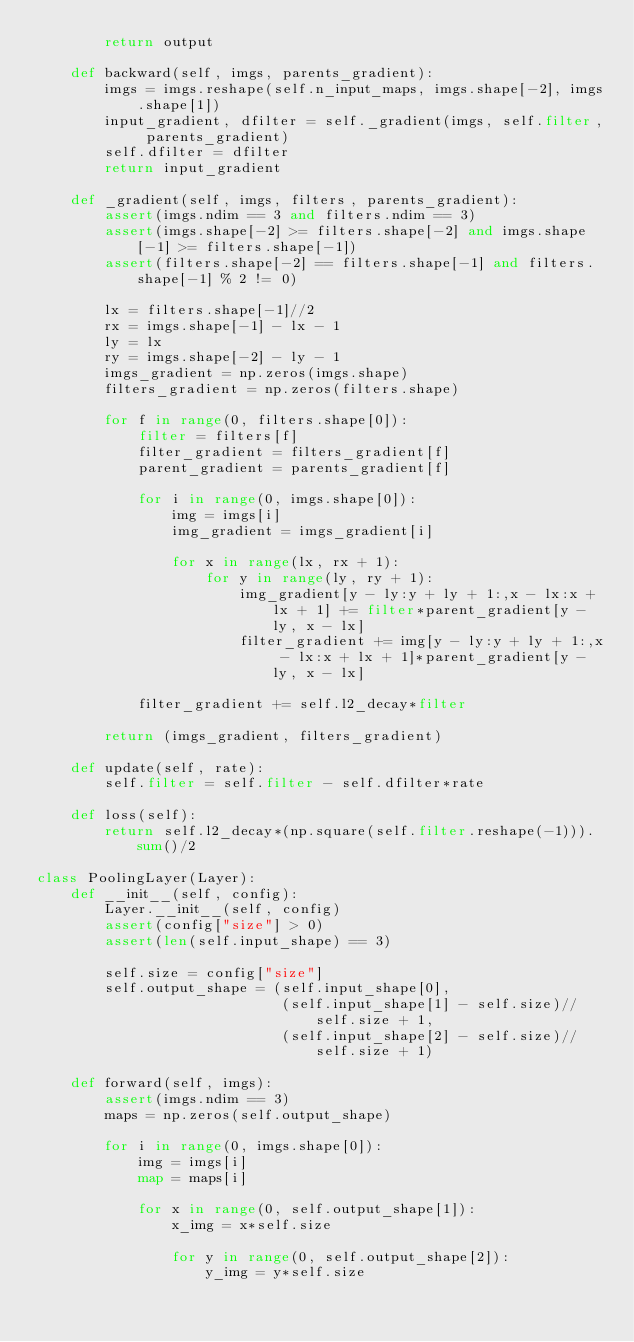Convert code to text. <code><loc_0><loc_0><loc_500><loc_500><_Python_>        return output

    def backward(self, imgs, parents_gradient):
        imgs = imgs.reshape(self.n_input_maps, imgs.shape[-2], imgs.shape[1])
        input_gradient, dfilter = self._gradient(imgs, self.filter, parents_gradient)
        self.dfilter = dfilter
        return input_gradient

    def _gradient(self, imgs, filters, parents_gradient):
        assert(imgs.ndim == 3 and filters.ndim == 3)
        assert(imgs.shape[-2] >= filters.shape[-2] and imgs.shape[-1] >= filters.shape[-1])
        assert(filters.shape[-2] == filters.shape[-1] and filters.shape[-1] % 2 != 0)

        lx = filters.shape[-1]//2
        rx = imgs.shape[-1] - lx - 1
        ly = lx
        ry = imgs.shape[-2] - ly - 1
        imgs_gradient = np.zeros(imgs.shape)
        filters_gradient = np.zeros(filters.shape)

        for f in range(0, filters.shape[0]):
            filter = filters[f]
            filter_gradient = filters_gradient[f]
            parent_gradient = parents_gradient[f]

            for i in range(0, imgs.shape[0]):
                img = imgs[i]
                img_gradient = imgs_gradient[i]

                for x in range(lx, rx + 1):
                    for y in range(ly, ry + 1):
                        img_gradient[y - ly:y + ly + 1:,x - lx:x + lx + 1] += filter*parent_gradient[y - ly, x - lx]
                        filter_gradient += img[y - ly:y + ly + 1:,x - lx:x + lx + 1]*parent_gradient[y - ly, x - lx]

            filter_gradient += self.l2_decay*filter

        return (imgs_gradient, filters_gradient)

    def update(self, rate):
        self.filter = self.filter - self.dfilter*rate

    def loss(self):
        return self.l2_decay*(np.square(self.filter.reshape(-1))).sum()/2

class PoolingLayer(Layer):
    def __init__(self, config):
        Layer.__init__(self, config)
        assert(config["size"] > 0)
        assert(len(self.input_shape) == 3)

        self.size = config["size"]
        self.output_shape = (self.input_shape[0],
                             (self.input_shape[1] - self.size)//self.size + 1,
                             (self.input_shape[2] - self.size)//self.size + 1)

    def forward(self, imgs):
        assert(imgs.ndim == 3)
        maps = np.zeros(self.output_shape)

        for i in range(0, imgs.shape[0]):
            img = imgs[i]
            map = maps[i]

            for x in range(0, self.output_shape[1]):
                x_img = x*self.size

                for y in range(0, self.output_shape[2]):
                    y_img = y*self.size</code> 